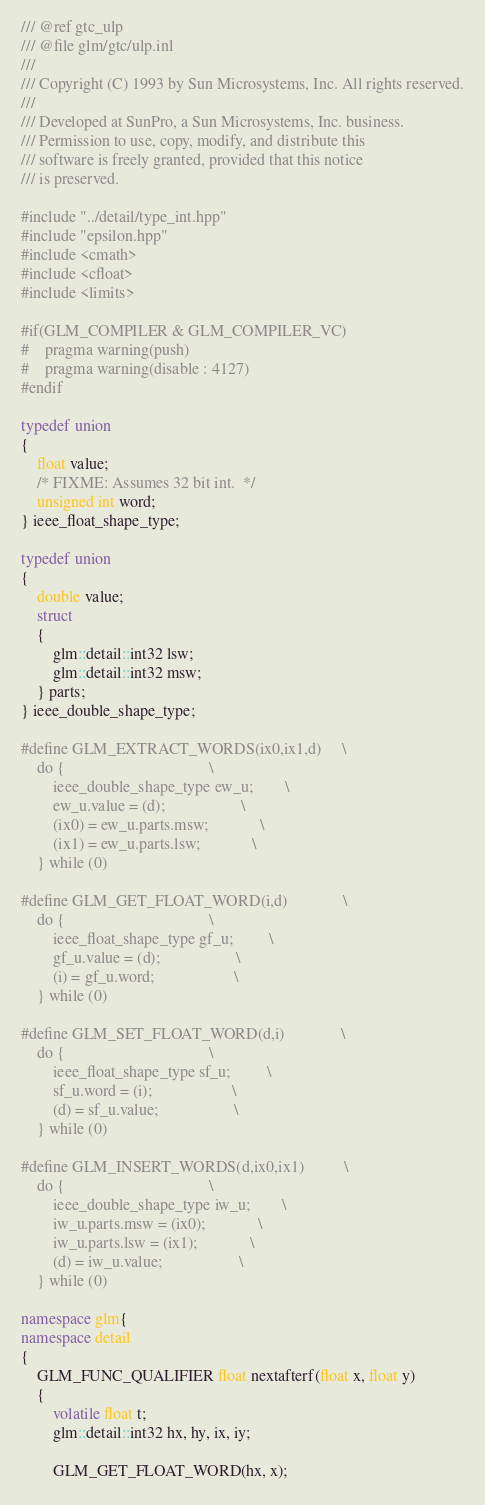Convert code to text. <code><loc_0><loc_0><loc_500><loc_500><_C++_>/// @ref gtc_ulp
/// @file glm/gtc/ulp.inl
///
/// Copyright (C) 1993 by Sun Microsystems, Inc. All rights reserved.
///
/// Developed at SunPro, a Sun Microsystems, Inc. business.
/// Permission to use, copy, modify, and distribute this
/// software is freely granted, provided that this notice
/// is preserved.

#include "../detail/type_int.hpp"
#include "epsilon.hpp"
#include <cmath>
#include <cfloat>
#include <limits>

#if(GLM_COMPILER & GLM_COMPILER_VC)
#	pragma warning(push)
#	pragma warning(disable : 4127)
#endif

typedef union
{
	float value;
	/* FIXME: Assumes 32 bit int.  */
	unsigned int word;
} ieee_float_shape_type;

typedef union
{
	double value;
	struct
	{
		glm::detail::int32 lsw;
		glm::detail::int32 msw;
	} parts;
} ieee_double_shape_type;

#define GLM_EXTRACT_WORDS(ix0,ix1,d)		\
	do {									\
		ieee_double_shape_type ew_u;		\
		ew_u.value = (d);					\
		(ix0) = ew_u.parts.msw;				\
		(ix1) = ew_u.parts.lsw;				\
	} while (0)

#define GLM_GET_FLOAT_WORD(i,d)				\
	do {									\
		ieee_float_shape_type gf_u;			\
		gf_u.value = (d);					\
		(i) = gf_u.word;					\
	} while (0)

#define GLM_SET_FLOAT_WORD(d,i)				\
	do {									\
		ieee_float_shape_type sf_u;			\
		sf_u.word = (i);					\
		(d) = sf_u.value;					\
	} while (0)

#define GLM_INSERT_WORDS(d,ix0,ix1)			\
	do {									\
		ieee_double_shape_type iw_u;		\
		iw_u.parts.msw = (ix0);				\
		iw_u.parts.lsw = (ix1);				\
		(d) = iw_u.value;					\
	} while (0)

namespace glm{
namespace detail
{
	GLM_FUNC_QUALIFIER float nextafterf(float x, float y)
	{
		volatile float t;
		glm::detail::int32 hx, hy, ix, iy;

		GLM_GET_FLOAT_WORD(hx, x);</code> 